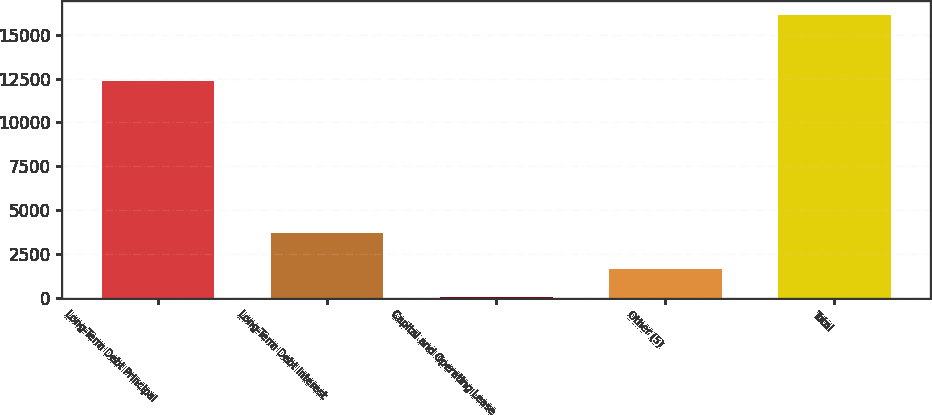Convert chart. <chart><loc_0><loc_0><loc_500><loc_500><bar_chart><fcel>Long-Term Debt Principal<fcel>Long-Term Debt Interest<fcel>Capital and Operating Lease<fcel>Other (5)<fcel>Total<nl><fcel>12376<fcel>3667<fcel>24<fcel>1632.6<fcel>16110<nl></chart> 